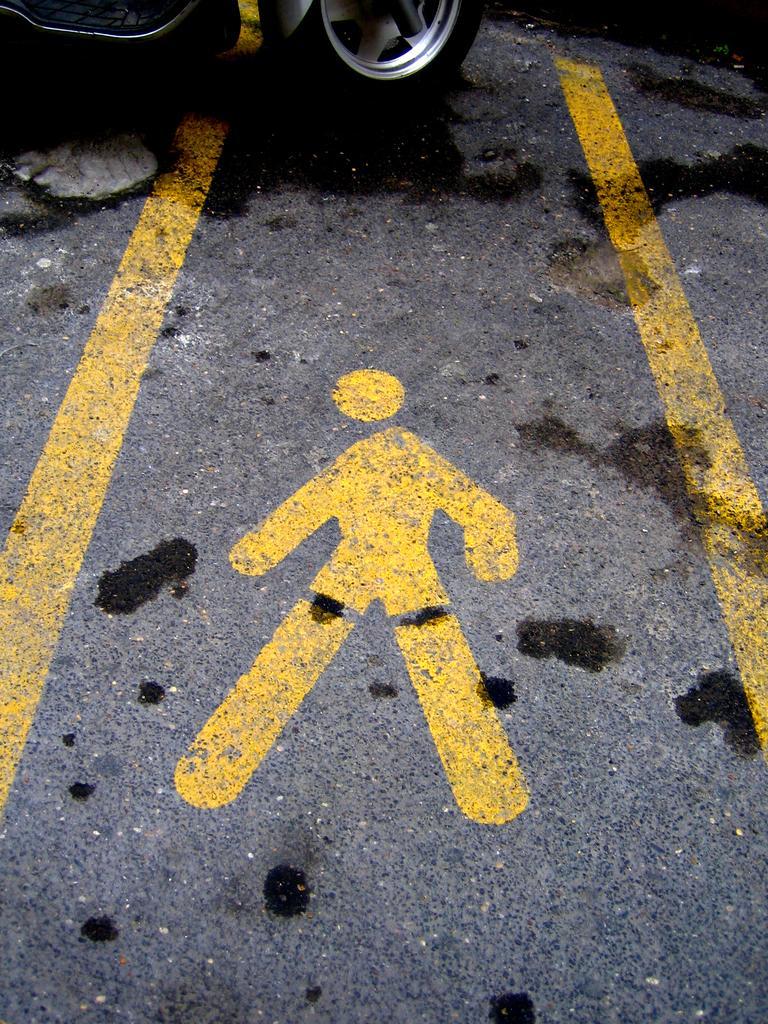How would you summarize this image in a sentence or two? In the image we can see the road and the yellow line and diagram on it. We can even see the vehicle. 